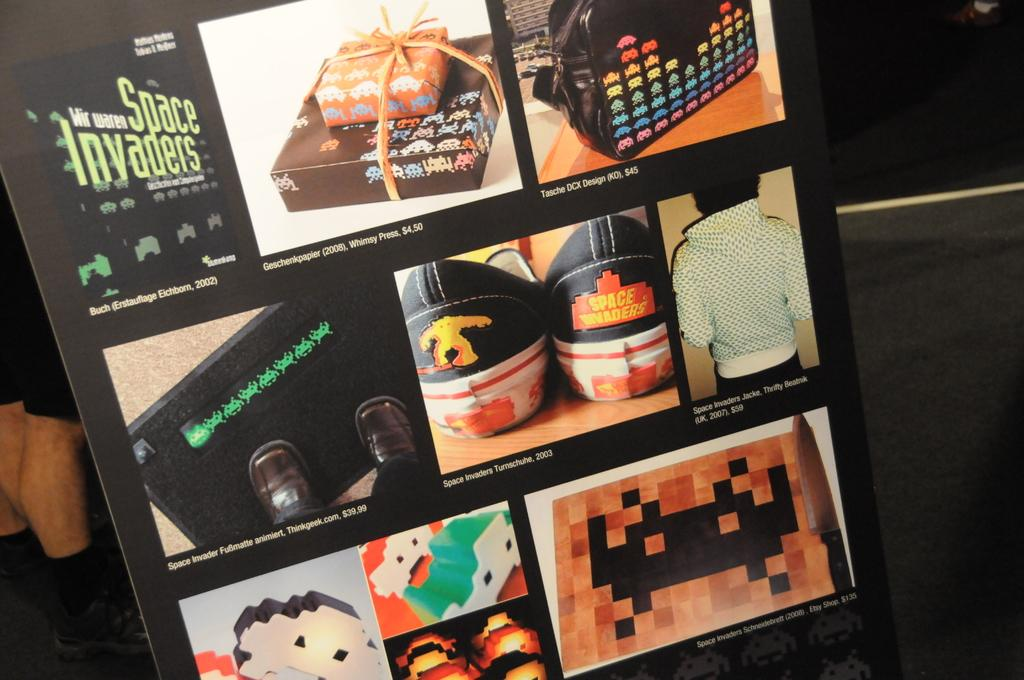<image>
Share a concise interpretation of the image provided. An ad for Space Invaders merchandise shows wrapping paper and shoes. 